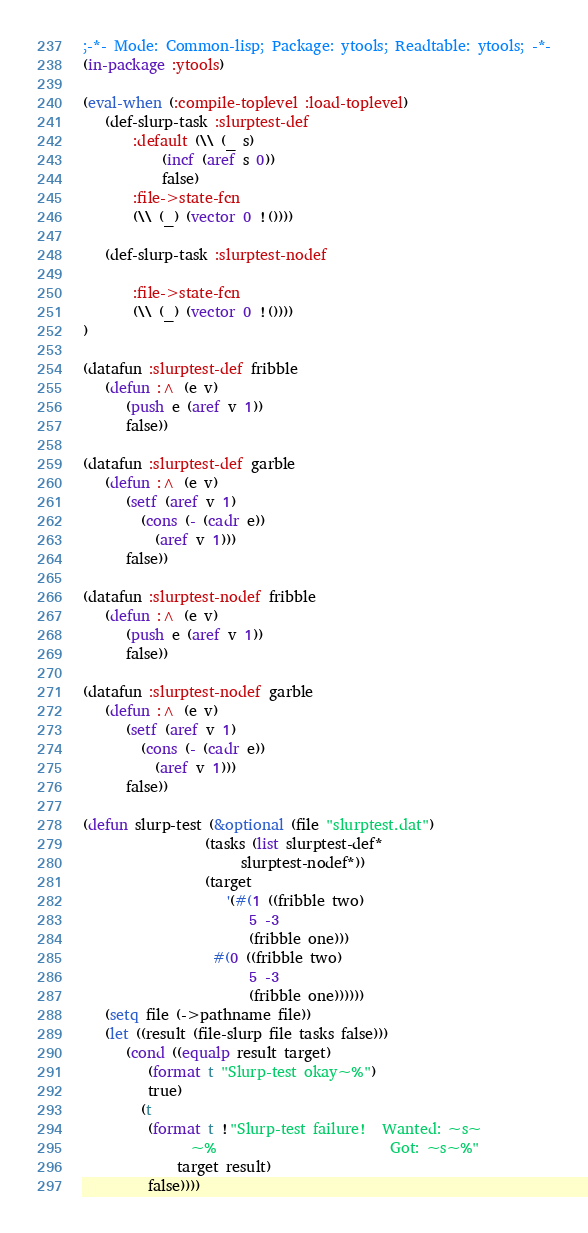Convert code to text. <code><loc_0><loc_0><loc_500><loc_500><_Lisp_>;-*- Mode: Common-lisp; Package: ytools; Readtable: ytools; -*-
(in-package :ytools)

(eval-when (:compile-toplevel :load-toplevel)
   (def-slurp-task :slurptest-def
       :default (\\ (_ s)
		   (incf (aref s 0))
		   false)
       :file->state-fcn
	   (\\ (_) (vector 0 !())))

   (def-slurp-task :slurptest-nodef

       :file->state-fcn
	   (\\ (_) (vector 0 !())))
)

(datafun :slurptest-def fribble
   (defun :^ (e v)
      (push e (aref v 1))
      false))

(datafun :slurptest-def garble
   (defun :^ (e v)
      (setf (aref v 1)
	    (cons (- (cadr e))
		  (aref v 1)))
      false))

(datafun :slurptest-nodef fribble
   (defun :^ (e v)
      (push e (aref v 1))
      false))

(datafun :slurptest-nodef garble
   (defun :^ (e v)
      (setf (aref v 1)
	    (cons (- (cadr e))
		  (aref v 1)))
      false))

(defun slurp-test (&optional (file "slurptest.dat")
			     (tasks (list slurptest-def*
					  slurptest-nodef*))
			     (target
			        '(#(1 ((fribble two)
				       5 -3
				       (fribble one)))
				  #(0 ((fribble two)
				       5 -3
				       (fribble one))))))
   (setq file (->pathname file))
   (let ((result (file-slurp file tasks false)))
      (cond ((equalp result target)
	     (format t "Slurp-test okay~%")
	     true)
	    (t
	     (format t !"Slurp-test failure!  Wanted: ~s~
		       ~%                        Got: ~s~%"
		     target result)
	     false))))</code> 